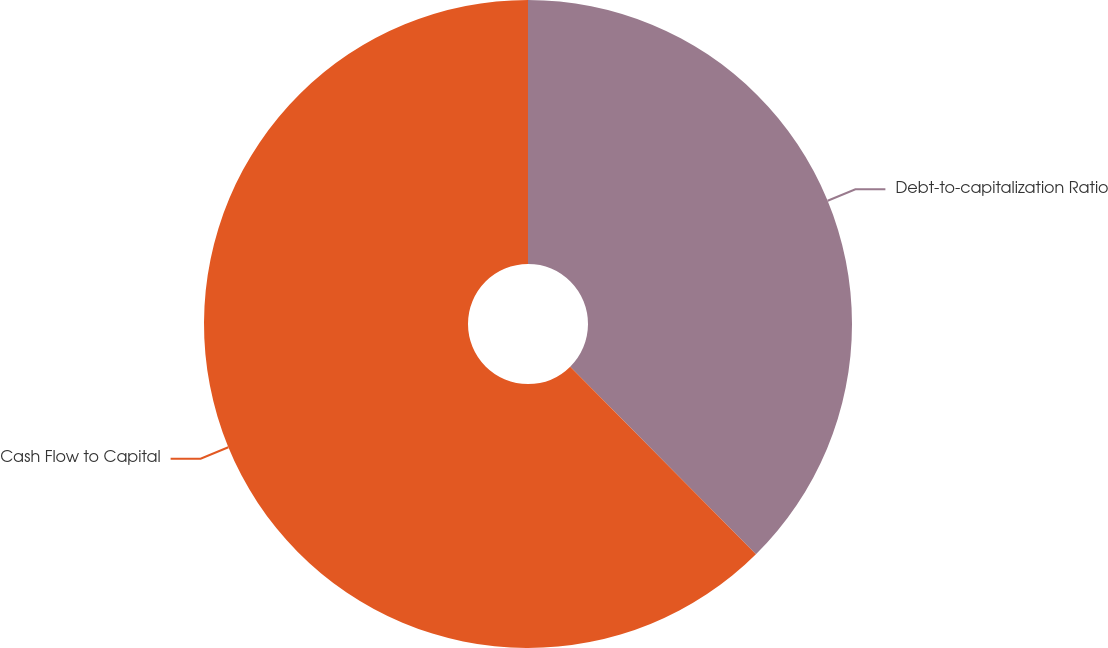Convert chart to OTSL. <chart><loc_0><loc_0><loc_500><loc_500><pie_chart><fcel>Debt-to-capitalization Ratio<fcel>Cash Flow to Capital<nl><fcel>37.58%<fcel>62.42%<nl></chart> 